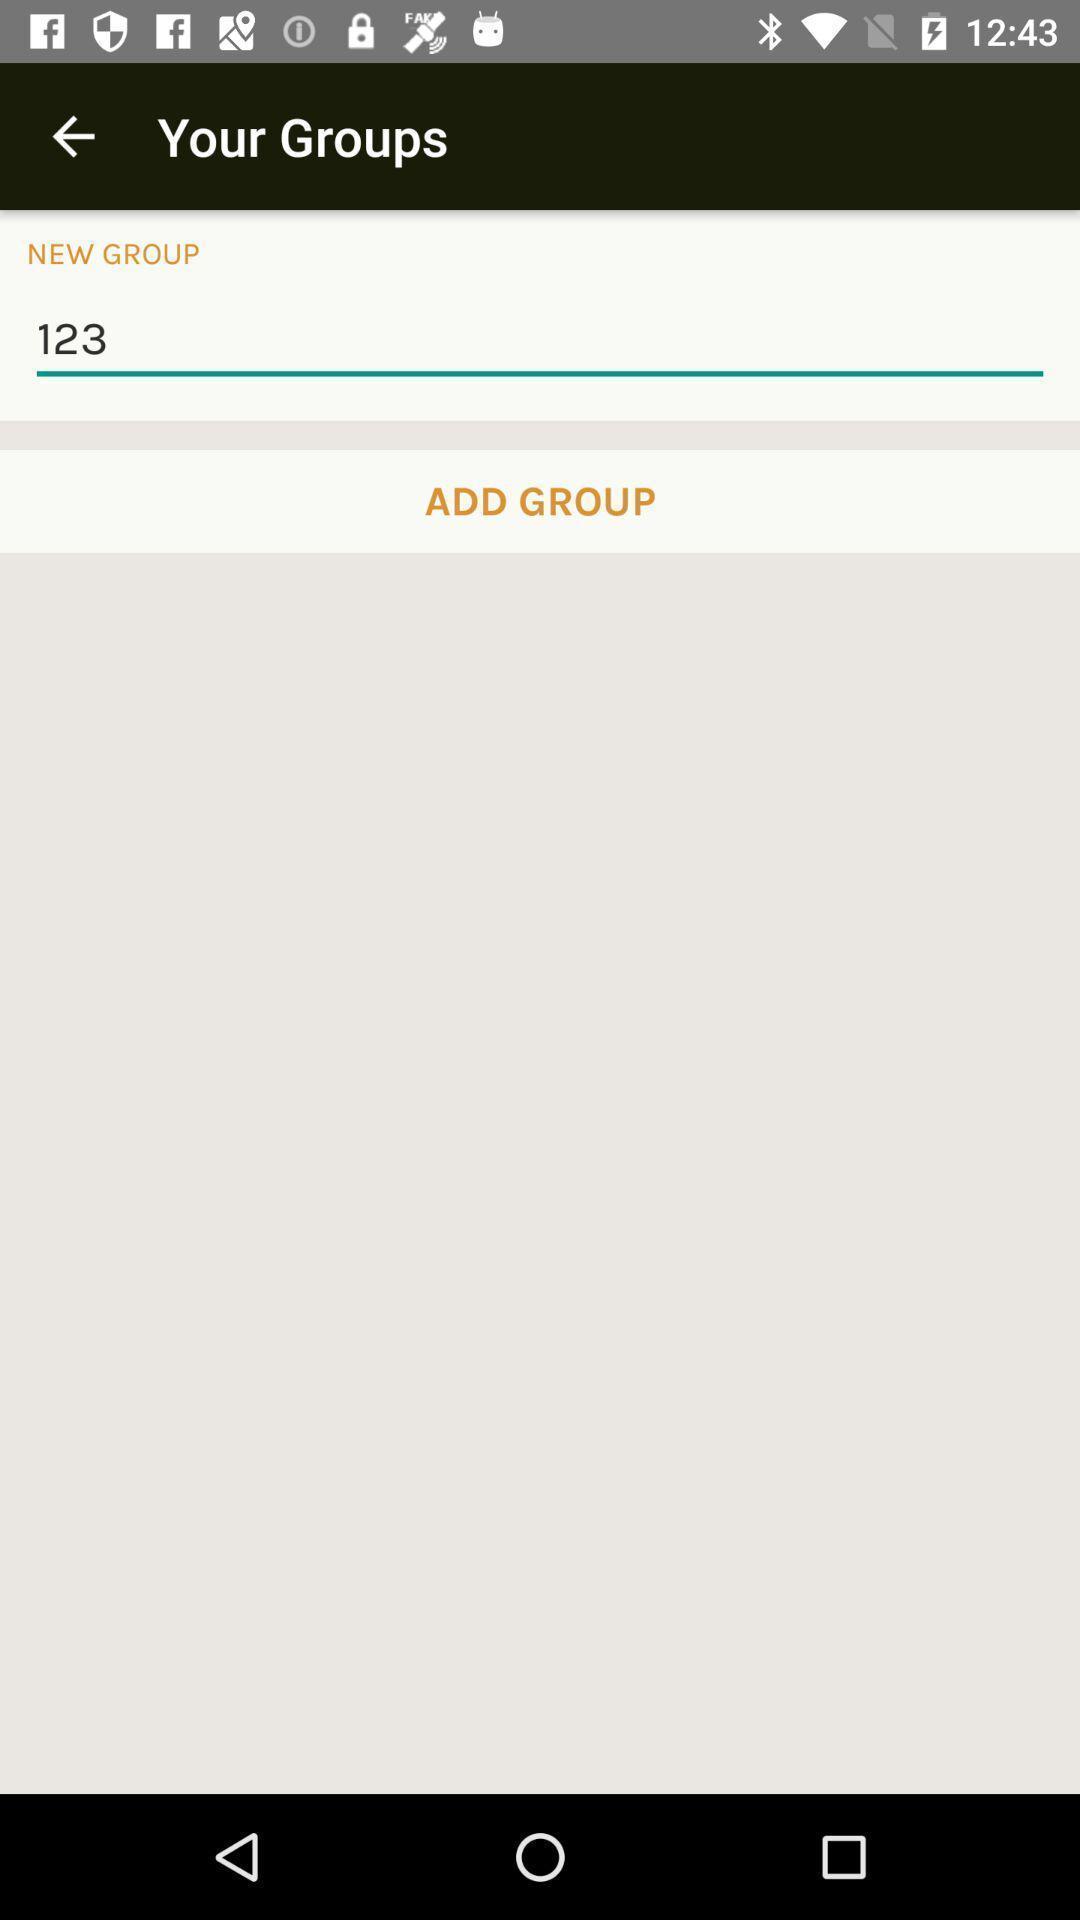Summarize the main components in this picture. Page showing the option for adding new group. 